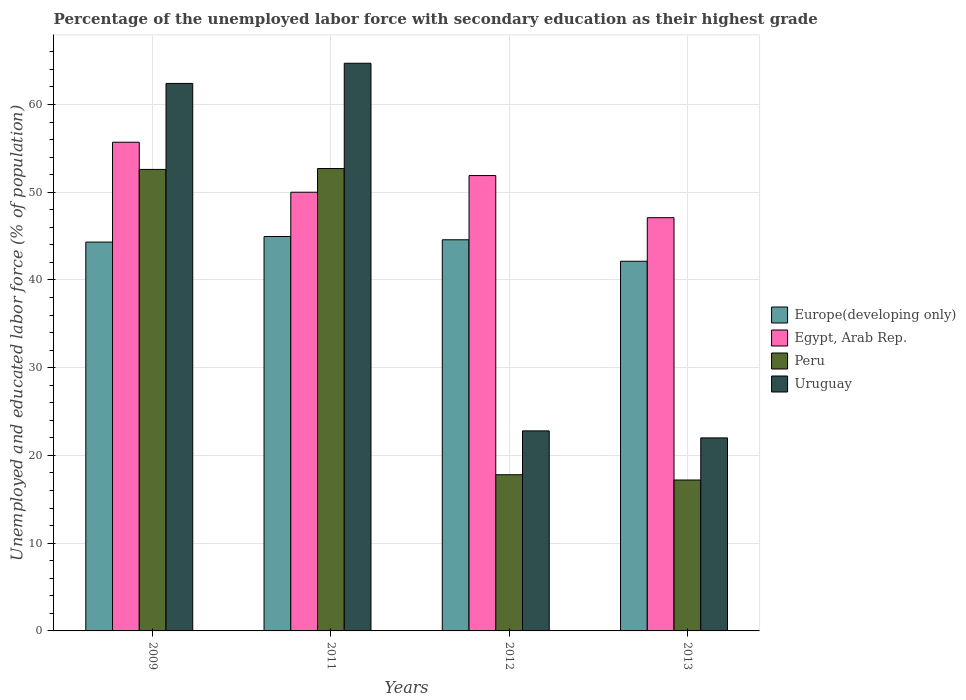How many different coloured bars are there?
Your answer should be very brief. 4. Are the number of bars per tick equal to the number of legend labels?
Offer a terse response. Yes. What is the percentage of the unemployed labor force with secondary education in Egypt, Arab Rep. in 2009?
Your answer should be very brief. 55.7. Across all years, what is the maximum percentage of the unemployed labor force with secondary education in Egypt, Arab Rep.?
Keep it short and to the point. 55.7. Across all years, what is the minimum percentage of the unemployed labor force with secondary education in Egypt, Arab Rep.?
Provide a succinct answer. 47.1. In which year was the percentage of the unemployed labor force with secondary education in Uruguay minimum?
Provide a succinct answer. 2013. What is the total percentage of the unemployed labor force with secondary education in Uruguay in the graph?
Keep it short and to the point. 171.9. What is the difference between the percentage of the unemployed labor force with secondary education in Uruguay in 2011 and that in 2012?
Provide a succinct answer. 41.9. What is the difference between the percentage of the unemployed labor force with secondary education in Peru in 2011 and the percentage of the unemployed labor force with secondary education in Europe(developing only) in 2012?
Keep it short and to the point. 8.12. What is the average percentage of the unemployed labor force with secondary education in Peru per year?
Provide a short and direct response. 35.07. In the year 2009, what is the difference between the percentage of the unemployed labor force with secondary education in Egypt, Arab Rep. and percentage of the unemployed labor force with secondary education in Uruguay?
Offer a terse response. -6.7. What is the ratio of the percentage of the unemployed labor force with secondary education in Peru in 2011 to that in 2012?
Ensure brevity in your answer.  2.96. What is the difference between the highest and the second highest percentage of the unemployed labor force with secondary education in Egypt, Arab Rep.?
Offer a terse response. 3.8. What is the difference between the highest and the lowest percentage of the unemployed labor force with secondary education in Egypt, Arab Rep.?
Keep it short and to the point. 8.6. Is the sum of the percentage of the unemployed labor force with secondary education in Europe(developing only) in 2009 and 2013 greater than the maximum percentage of the unemployed labor force with secondary education in Uruguay across all years?
Ensure brevity in your answer.  Yes. What does the 3rd bar from the left in 2012 represents?
Your answer should be compact. Peru. What does the 1st bar from the right in 2009 represents?
Provide a succinct answer. Uruguay. How many bars are there?
Your response must be concise. 16. What is the difference between two consecutive major ticks on the Y-axis?
Provide a succinct answer. 10. Are the values on the major ticks of Y-axis written in scientific E-notation?
Offer a very short reply. No. Does the graph contain any zero values?
Give a very brief answer. No. How are the legend labels stacked?
Offer a terse response. Vertical. What is the title of the graph?
Your answer should be very brief. Percentage of the unemployed labor force with secondary education as their highest grade. Does "Saudi Arabia" appear as one of the legend labels in the graph?
Keep it short and to the point. No. What is the label or title of the X-axis?
Provide a succinct answer. Years. What is the label or title of the Y-axis?
Ensure brevity in your answer.  Unemployed and educated labor force (% of population). What is the Unemployed and educated labor force (% of population) in Europe(developing only) in 2009?
Offer a very short reply. 44.32. What is the Unemployed and educated labor force (% of population) of Egypt, Arab Rep. in 2009?
Your answer should be compact. 55.7. What is the Unemployed and educated labor force (% of population) of Peru in 2009?
Your answer should be compact. 52.6. What is the Unemployed and educated labor force (% of population) of Uruguay in 2009?
Make the answer very short. 62.4. What is the Unemployed and educated labor force (% of population) in Europe(developing only) in 2011?
Provide a short and direct response. 44.96. What is the Unemployed and educated labor force (% of population) of Peru in 2011?
Provide a short and direct response. 52.7. What is the Unemployed and educated labor force (% of population) of Uruguay in 2011?
Offer a very short reply. 64.7. What is the Unemployed and educated labor force (% of population) of Europe(developing only) in 2012?
Ensure brevity in your answer.  44.58. What is the Unemployed and educated labor force (% of population) in Egypt, Arab Rep. in 2012?
Keep it short and to the point. 51.9. What is the Unemployed and educated labor force (% of population) in Peru in 2012?
Your answer should be compact. 17.8. What is the Unemployed and educated labor force (% of population) in Uruguay in 2012?
Your response must be concise. 22.8. What is the Unemployed and educated labor force (% of population) of Europe(developing only) in 2013?
Offer a very short reply. 42.13. What is the Unemployed and educated labor force (% of population) in Egypt, Arab Rep. in 2013?
Ensure brevity in your answer.  47.1. What is the Unemployed and educated labor force (% of population) in Peru in 2013?
Provide a short and direct response. 17.2. What is the Unemployed and educated labor force (% of population) of Uruguay in 2013?
Make the answer very short. 22. Across all years, what is the maximum Unemployed and educated labor force (% of population) of Europe(developing only)?
Keep it short and to the point. 44.96. Across all years, what is the maximum Unemployed and educated labor force (% of population) in Egypt, Arab Rep.?
Provide a succinct answer. 55.7. Across all years, what is the maximum Unemployed and educated labor force (% of population) in Peru?
Offer a very short reply. 52.7. Across all years, what is the maximum Unemployed and educated labor force (% of population) in Uruguay?
Make the answer very short. 64.7. Across all years, what is the minimum Unemployed and educated labor force (% of population) of Europe(developing only)?
Your response must be concise. 42.13. Across all years, what is the minimum Unemployed and educated labor force (% of population) in Egypt, Arab Rep.?
Keep it short and to the point. 47.1. Across all years, what is the minimum Unemployed and educated labor force (% of population) in Peru?
Make the answer very short. 17.2. Across all years, what is the minimum Unemployed and educated labor force (% of population) of Uruguay?
Your answer should be compact. 22. What is the total Unemployed and educated labor force (% of population) in Europe(developing only) in the graph?
Offer a terse response. 175.99. What is the total Unemployed and educated labor force (% of population) of Egypt, Arab Rep. in the graph?
Provide a succinct answer. 204.7. What is the total Unemployed and educated labor force (% of population) of Peru in the graph?
Your answer should be compact. 140.3. What is the total Unemployed and educated labor force (% of population) in Uruguay in the graph?
Your response must be concise. 171.9. What is the difference between the Unemployed and educated labor force (% of population) in Europe(developing only) in 2009 and that in 2011?
Give a very brief answer. -0.64. What is the difference between the Unemployed and educated labor force (% of population) of Peru in 2009 and that in 2011?
Offer a very short reply. -0.1. What is the difference between the Unemployed and educated labor force (% of population) in Uruguay in 2009 and that in 2011?
Give a very brief answer. -2.3. What is the difference between the Unemployed and educated labor force (% of population) in Europe(developing only) in 2009 and that in 2012?
Your response must be concise. -0.26. What is the difference between the Unemployed and educated labor force (% of population) in Egypt, Arab Rep. in 2009 and that in 2012?
Ensure brevity in your answer.  3.8. What is the difference between the Unemployed and educated labor force (% of population) in Peru in 2009 and that in 2012?
Make the answer very short. 34.8. What is the difference between the Unemployed and educated labor force (% of population) in Uruguay in 2009 and that in 2012?
Your answer should be compact. 39.6. What is the difference between the Unemployed and educated labor force (% of population) in Europe(developing only) in 2009 and that in 2013?
Your answer should be very brief. 2.19. What is the difference between the Unemployed and educated labor force (% of population) of Egypt, Arab Rep. in 2009 and that in 2013?
Your answer should be very brief. 8.6. What is the difference between the Unemployed and educated labor force (% of population) in Peru in 2009 and that in 2013?
Offer a terse response. 35.4. What is the difference between the Unemployed and educated labor force (% of population) of Uruguay in 2009 and that in 2013?
Give a very brief answer. 40.4. What is the difference between the Unemployed and educated labor force (% of population) of Europe(developing only) in 2011 and that in 2012?
Provide a succinct answer. 0.37. What is the difference between the Unemployed and educated labor force (% of population) of Peru in 2011 and that in 2012?
Ensure brevity in your answer.  34.9. What is the difference between the Unemployed and educated labor force (% of population) of Uruguay in 2011 and that in 2012?
Your answer should be very brief. 41.9. What is the difference between the Unemployed and educated labor force (% of population) of Europe(developing only) in 2011 and that in 2013?
Offer a terse response. 2.82. What is the difference between the Unemployed and educated labor force (% of population) of Egypt, Arab Rep. in 2011 and that in 2013?
Give a very brief answer. 2.9. What is the difference between the Unemployed and educated labor force (% of population) in Peru in 2011 and that in 2013?
Provide a succinct answer. 35.5. What is the difference between the Unemployed and educated labor force (% of population) in Uruguay in 2011 and that in 2013?
Provide a short and direct response. 42.7. What is the difference between the Unemployed and educated labor force (% of population) of Europe(developing only) in 2012 and that in 2013?
Your answer should be very brief. 2.45. What is the difference between the Unemployed and educated labor force (% of population) of Egypt, Arab Rep. in 2012 and that in 2013?
Make the answer very short. 4.8. What is the difference between the Unemployed and educated labor force (% of population) of Europe(developing only) in 2009 and the Unemployed and educated labor force (% of population) of Egypt, Arab Rep. in 2011?
Provide a short and direct response. -5.68. What is the difference between the Unemployed and educated labor force (% of population) in Europe(developing only) in 2009 and the Unemployed and educated labor force (% of population) in Peru in 2011?
Make the answer very short. -8.38. What is the difference between the Unemployed and educated labor force (% of population) in Europe(developing only) in 2009 and the Unemployed and educated labor force (% of population) in Uruguay in 2011?
Your answer should be compact. -20.38. What is the difference between the Unemployed and educated labor force (% of population) of Egypt, Arab Rep. in 2009 and the Unemployed and educated labor force (% of population) of Uruguay in 2011?
Give a very brief answer. -9. What is the difference between the Unemployed and educated labor force (% of population) of Peru in 2009 and the Unemployed and educated labor force (% of population) of Uruguay in 2011?
Offer a very short reply. -12.1. What is the difference between the Unemployed and educated labor force (% of population) in Europe(developing only) in 2009 and the Unemployed and educated labor force (% of population) in Egypt, Arab Rep. in 2012?
Offer a terse response. -7.58. What is the difference between the Unemployed and educated labor force (% of population) of Europe(developing only) in 2009 and the Unemployed and educated labor force (% of population) of Peru in 2012?
Ensure brevity in your answer.  26.52. What is the difference between the Unemployed and educated labor force (% of population) in Europe(developing only) in 2009 and the Unemployed and educated labor force (% of population) in Uruguay in 2012?
Provide a short and direct response. 21.52. What is the difference between the Unemployed and educated labor force (% of population) of Egypt, Arab Rep. in 2009 and the Unemployed and educated labor force (% of population) of Peru in 2012?
Ensure brevity in your answer.  37.9. What is the difference between the Unemployed and educated labor force (% of population) of Egypt, Arab Rep. in 2009 and the Unemployed and educated labor force (% of population) of Uruguay in 2012?
Offer a terse response. 32.9. What is the difference between the Unemployed and educated labor force (% of population) of Peru in 2009 and the Unemployed and educated labor force (% of population) of Uruguay in 2012?
Your response must be concise. 29.8. What is the difference between the Unemployed and educated labor force (% of population) of Europe(developing only) in 2009 and the Unemployed and educated labor force (% of population) of Egypt, Arab Rep. in 2013?
Offer a very short reply. -2.78. What is the difference between the Unemployed and educated labor force (% of population) of Europe(developing only) in 2009 and the Unemployed and educated labor force (% of population) of Peru in 2013?
Provide a short and direct response. 27.12. What is the difference between the Unemployed and educated labor force (% of population) of Europe(developing only) in 2009 and the Unemployed and educated labor force (% of population) of Uruguay in 2013?
Give a very brief answer. 22.32. What is the difference between the Unemployed and educated labor force (% of population) in Egypt, Arab Rep. in 2009 and the Unemployed and educated labor force (% of population) in Peru in 2013?
Keep it short and to the point. 38.5. What is the difference between the Unemployed and educated labor force (% of population) in Egypt, Arab Rep. in 2009 and the Unemployed and educated labor force (% of population) in Uruguay in 2013?
Your answer should be very brief. 33.7. What is the difference between the Unemployed and educated labor force (% of population) in Peru in 2009 and the Unemployed and educated labor force (% of population) in Uruguay in 2013?
Offer a terse response. 30.6. What is the difference between the Unemployed and educated labor force (% of population) in Europe(developing only) in 2011 and the Unemployed and educated labor force (% of population) in Egypt, Arab Rep. in 2012?
Ensure brevity in your answer.  -6.94. What is the difference between the Unemployed and educated labor force (% of population) of Europe(developing only) in 2011 and the Unemployed and educated labor force (% of population) of Peru in 2012?
Ensure brevity in your answer.  27.16. What is the difference between the Unemployed and educated labor force (% of population) of Europe(developing only) in 2011 and the Unemployed and educated labor force (% of population) of Uruguay in 2012?
Give a very brief answer. 22.16. What is the difference between the Unemployed and educated labor force (% of population) in Egypt, Arab Rep. in 2011 and the Unemployed and educated labor force (% of population) in Peru in 2012?
Offer a terse response. 32.2. What is the difference between the Unemployed and educated labor force (% of population) in Egypt, Arab Rep. in 2011 and the Unemployed and educated labor force (% of population) in Uruguay in 2012?
Make the answer very short. 27.2. What is the difference between the Unemployed and educated labor force (% of population) of Peru in 2011 and the Unemployed and educated labor force (% of population) of Uruguay in 2012?
Make the answer very short. 29.9. What is the difference between the Unemployed and educated labor force (% of population) in Europe(developing only) in 2011 and the Unemployed and educated labor force (% of population) in Egypt, Arab Rep. in 2013?
Offer a very short reply. -2.14. What is the difference between the Unemployed and educated labor force (% of population) in Europe(developing only) in 2011 and the Unemployed and educated labor force (% of population) in Peru in 2013?
Provide a short and direct response. 27.76. What is the difference between the Unemployed and educated labor force (% of population) in Europe(developing only) in 2011 and the Unemployed and educated labor force (% of population) in Uruguay in 2013?
Ensure brevity in your answer.  22.96. What is the difference between the Unemployed and educated labor force (% of population) of Egypt, Arab Rep. in 2011 and the Unemployed and educated labor force (% of population) of Peru in 2013?
Give a very brief answer. 32.8. What is the difference between the Unemployed and educated labor force (% of population) in Peru in 2011 and the Unemployed and educated labor force (% of population) in Uruguay in 2013?
Offer a terse response. 30.7. What is the difference between the Unemployed and educated labor force (% of population) in Europe(developing only) in 2012 and the Unemployed and educated labor force (% of population) in Egypt, Arab Rep. in 2013?
Provide a short and direct response. -2.52. What is the difference between the Unemployed and educated labor force (% of population) of Europe(developing only) in 2012 and the Unemployed and educated labor force (% of population) of Peru in 2013?
Your response must be concise. 27.38. What is the difference between the Unemployed and educated labor force (% of population) of Europe(developing only) in 2012 and the Unemployed and educated labor force (% of population) of Uruguay in 2013?
Provide a short and direct response. 22.58. What is the difference between the Unemployed and educated labor force (% of population) in Egypt, Arab Rep. in 2012 and the Unemployed and educated labor force (% of population) in Peru in 2013?
Your answer should be very brief. 34.7. What is the difference between the Unemployed and educated labor force (% of population) in Egypt, Arab Rep. in 2012 and the Unemployed and educated labor force (% of population) in Uruguay in 2013?
Provide a succinct answer. 29.9. What is the average Unemployed and educated labor force (% of population) of Europe(developing only) per year?
Keep it short and to the point. 44. What is the average Unemployed and educated labor force (% of population) of Egypt, Arab Rep. per year?
Provide a short and direct response. 51.17. What is the average Unemployed and educated labor force (% of population) of Peru per year?
Ensure brevity in your answer.  35.08. What is the average Unemployed and educated labor force (% of population) of Uruguay per year?
Keep it short and to the point. 42.98. In the year 2009, what is the difference between the Unemployed and educated labor force (% of population) in Europe(developing only) and Unemployed and educated labor force (% of population) in Egypt, Arab Rep.?
Ensure brevity in your answer.  -11.38. In the year 2009, what is the difference between the Unemployed and educated labor force (% of population) of Europe(developing only) and Unemployed and educated labor force (% of population) of Peru?
Keep it short and to the point. -8.28. In the year 2009, what is the difference between the Unemployed and educated labor force (% of population) of Europe(developing only) and Unemployed and educated labor force (% of population) of Uruguay?
Your answer should be compact. -18.08. In the year 2009, what is the difference between the Unemployed and educated labor force (% of population) of Egypt, Arab Rep. and Unemployed and educated labor force (% of population) of Peru?
Offer a terse response. 3.1. In the year 2011, what is the difference between the Unemployed and educated labor force (% of population) of Europe(developing only) and Unemployed and educated labor force (% of population) of Egypt, Arab Rep.?
Give a very brief answer. -5.04. In the year 2011, what is the difference between the Unemployed and educated labor force (% of population) in Europe(developing only) and Unemployed and educated labor force (% of population) in Peru?
Your answer should be compact. -7.74. In the year 2011, what is the difference between the Unemployed and educated labor force (% of population) in Europe(developing only) and Unemployed and educated labor force (% of population) in Uruguay?
Offer a terse response. -19.74. In the year 2011, what is the difference between the Unemployed and educated labor force (% of population) of Egypt, Arab Rep. and Unemployed and educated labor force (% of population) of Uruguay?
Give a very brief answer. -14.7. In the year 2011, what is the difference between the Unemployed and educated labor force (% of population) of Peru and Unemployed and educated labor force (% of population) of Uruguay?
Ensure brevity in your answer.  -12. In the year 2012, what is the difference between the Unemployed and educated labor force (% of population) in Europe(developing only) and Unemployed and educated labor force (% of population) in Egypt, Arab Rep.?
Ensure brevity in your answer.  -7.32. In the year 2012, what is the difference between the Unemployed and educated labor force (% of population) in Europe(developing only) and Unemployed and educated labor force (% of population) in Peru?
Your response must be concise. 26.78. In the year 2012, what is the difference between the Unemployed and educated labor force (% of population) in Europe(developing only) and Unemployed and educated labor force (% of population) in Uruguay?
Your answer should be very brief. 21.78. In the year 2012, what is the difference between the Unemployed and educated labor force (% of population) in Egypt, Arab Rep. and Unemployed and educated labor force (% of population) in Peru?
Make the answer very short. 34.1. In the year 2012, what is the difference between the Unemployed and educated labor force (% of population) in Egypt, Arab Rep. and Unemployed and educated labor force (% of population) in Uruguay?
Your answer should be very brief. 29.1. In the year 2013, what is the difference between the Unemployed and educated labor force (% of population) of Europe(developing only) and Unemployed and educated labor force (% of population) of Egypt, Arab Rep.?
Keep it short and to the point. -4.97. In the year 2013, what is the difference between the Unemployed and educated labor force (% of population) of Europe(developing only) and Unemployed and educated labor force (% of population) of Peru?
Provide a succinct answer. 24.93. In the year 2013, what is the difference between the Unemployed and educated labor force (% of population) in Europe(developing only) and Unemployed and educated labor force (% of population) in Uruguay?
Offer a terse response. 20.13. In the year 2013, what is the difference between the Unemployed and educated labor force (% of population) in Egypt, Arab Rep. and Unemployed and educated labor force (% of population) in Peru?
Keep it short and to the point. 29.9. In the year 2013, what is the difference between the Unemployed and educated labor force (% of population) in Egypt, Arab Rep. and Unemployed and educated labor force (% of population) in Uruguay?
Provide a succinct answer. 25.1. In the year 2013, what is the difference between the Unemployed and educated labor force (% of population) of Peru and Unemployed and educated labor force (% of population) of Uruguay?
Provide a succinct answer. -4.8. What is the ratio of the Unemployed and educated labor force (% of population) in Europe(developing only) in 2009 to that in 2011?
Provide a succinct answer. 0.99. What is the ratio of the Unemployed and educated labor force (% of population) in Egypt, Arab Rep. in 2009 to that in 2011?
Offer a terse response. 1.11. What is the ratio of the Unemployed and educated labor force (% of population) in Uruguay in 2009 to that in 2011?
Give a very brief answer. 0.96. What is the ratio of the Unemployed and educated labor force (% of population) in Europe(developing only) in 2009 to that in 2012?
Keep it short and to the point. 0.99. What is the ratio of the Unemployed and educated labor force (% of population) of Egypt, Arab Rep. in 2009 to that in 2012?
Provide a succinct answer. 1.07. What is the ratio of the Unemployed and educated labor force (% of population) of Peru in 2009 to that in 2012?
Ensure brevity in your answer.  2.96. What is the ratio of the Unemployed and educated labor force (% of population) of Uruguay in 2009 to that in 2012?
Provide a short and direct response. 2.74. What is the ratio of the Unemployed and educated labor force (% of population) in Europe(developing only) in 2009 to that in 2013?
Provide a short and direct response. 1.05. What is the ratio of the Unemployed and educated labor force (% of population) in Egypt, Arab Rep. in 2009 to that in 2013?
Your response must be concise. 1.18. What is the ratio of the Unemployed and educated labor force (% of population) of Peru in 2009 to that in 2013?
Offer a terse response. 3.06. What is the ratio of the Unemployed and educated labor force (% of population) in Uruguay in 2009 to that in 2013?
Offer a very short reply. 2.84. What is the ratio of the Unemployed and educated labor force (% of population) in Europe(developing only) in 2011 to that in 2012?
Keep it short and to the point. 1.01. What is the ratio of the Unemployed and educated labor force (% of population) in Egypt, Arab Rep. in 2011 to that in 2012?
Ensure brevity in your answer.  0.96. What is the ratio of the Unemployed and educated labor force (% of population) in Peru in 2011 to that in 2012?
Offer a very short reply. 2.96. What is the ratio of the Unemployed and educated labor force (% of population) of Uruguay in 2011 to that in 2012?
Give a very brief answer. 2.84. What is the ratio of the Unemployed and educated labor force (% of population) in Europe(developing only) in 2011 to that in 2013?
Offer a terse response. 1.07. What is the ratio of the Unemployed and educated labor force (% of population) of Egypt, Arab Rep. in 2011 to that in 2013?
Keep it short and to the point. 1.06. What is the ratio of the Unemployed and educated labor force (% of population) of Peru in 2011 to that in 2013?
Your response must be concise. 3.06. What is the ratio of the Unemployed and educated labor force (% of population) of Uruguay in 2011 to that in 2013?
Your answer should be compact. 2.94. What is the ratio of the Unemployed and educated labor force (% of population) of Europe(developing only) in 2012 to that in 2013?
Keep it short and to the point. 1.06. What is the ratio of the Unemployed and educated labor force (% of population) of Egypt, Arab Rep. in 2012 to that in 2013?
Provide a short and direct response. 1.1. What is the ratio of the Unemployed and educated labor force (% of population) of Peru in 2012 to that in 2013?
Offer a very short reply. 1.03. What is the ratio of the Unemployed and educated labor force (% of population) of Uruguay in 2012 to that in 2013?
Make the answer very short. 1.04. What is the difference between the highest and the second highest Unemployed and educated labor force (% of population) in Europe(developing only)?
Your response must be concise. 0.37. What is the difference between the highest and the second highest Unemployed and educated labor force (% of population) in Egypt, Arab Rep.?
Offer a terse response. 3.8. What is the difference between the highest and the lowest Unemployed and educated labor force (% of population) of Europe(developing only)?
Give a very brief answer. 2.82. What is the difference between the highest and the lowest Unemployed and educated labor force (% of population) of Peru?
Offer a very short reply. 35.5. What is the difference between the highest and the lowest Unemployed and educated labor force (% of population) of Uruguay?
Provide a succinct answer. 42.7. 